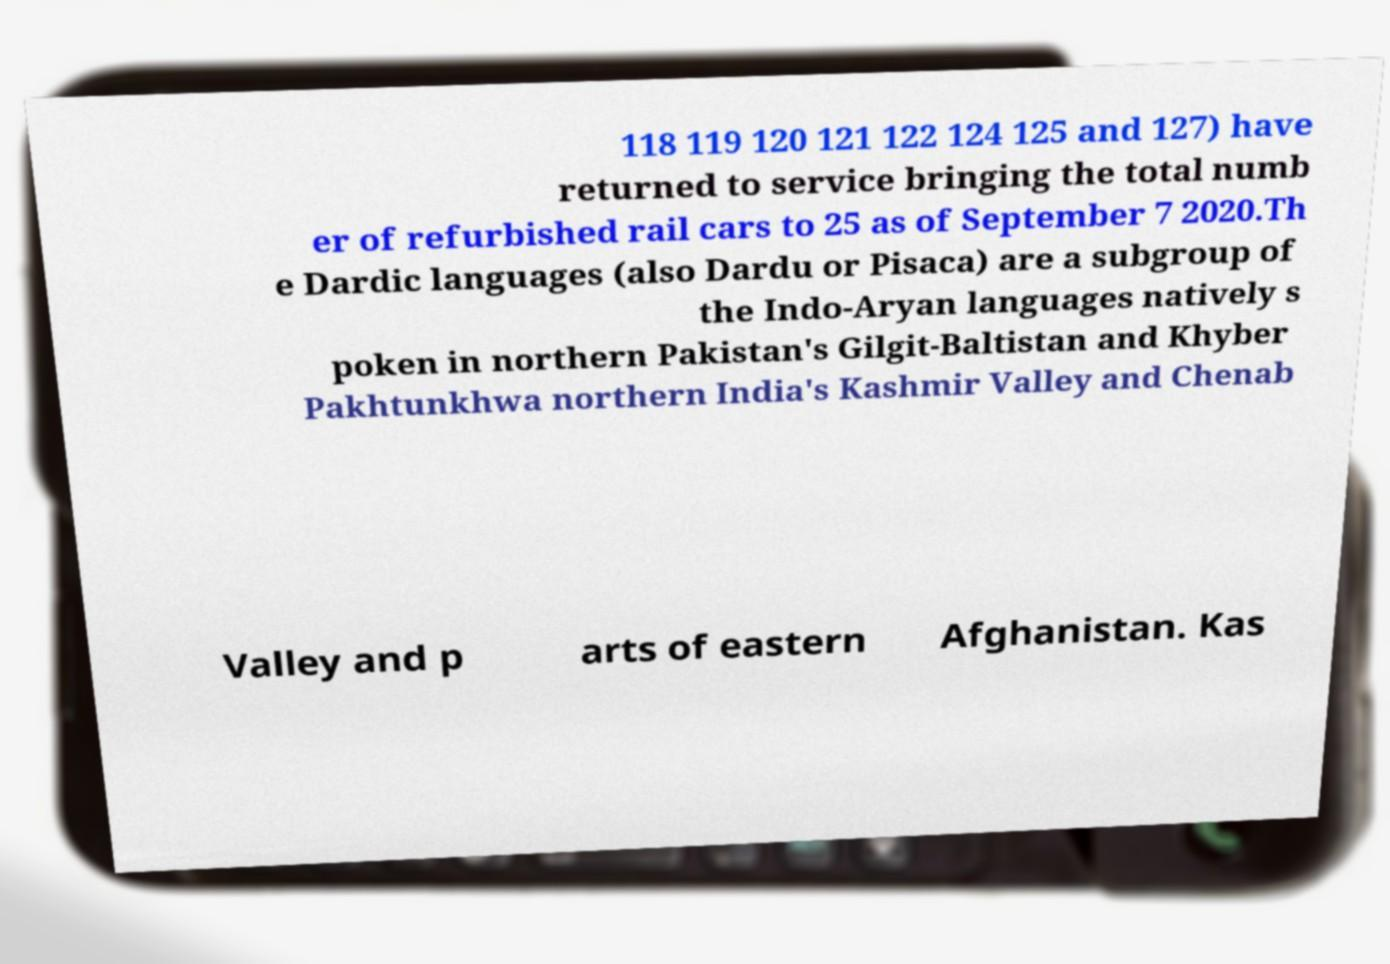Could you assist in decoding the text presented in this image and type it out clearly? 118 119 120 121 122 124 125 and 127) have returned to service bringing the total numb er of refurbished rail cars to 25 as of September 7 2020.Th e Dardic languages (also Dardu or Pisaca) are a subgroup of the Indo-Aryan languages natively s poken in northern Pakistan's Gilgit-Baltistan and Khyber Pakhtunkhwa northern India's Kashmir Valley and Chenab Valley and p arts of eastern Afghanistan. Kas 